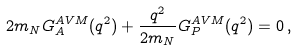<formula> <loc_0><loc_0><loc_500><loc_500>2 m _ { N } G _ { A } ^ { A V M } ( q ^ { 2 } ) + \frac { q ^ { 2 } } { 2 m _ { N } } G _ { P } ^ { A V M } ( q ^ { 2 } ) = 0 \, ,</formula> 